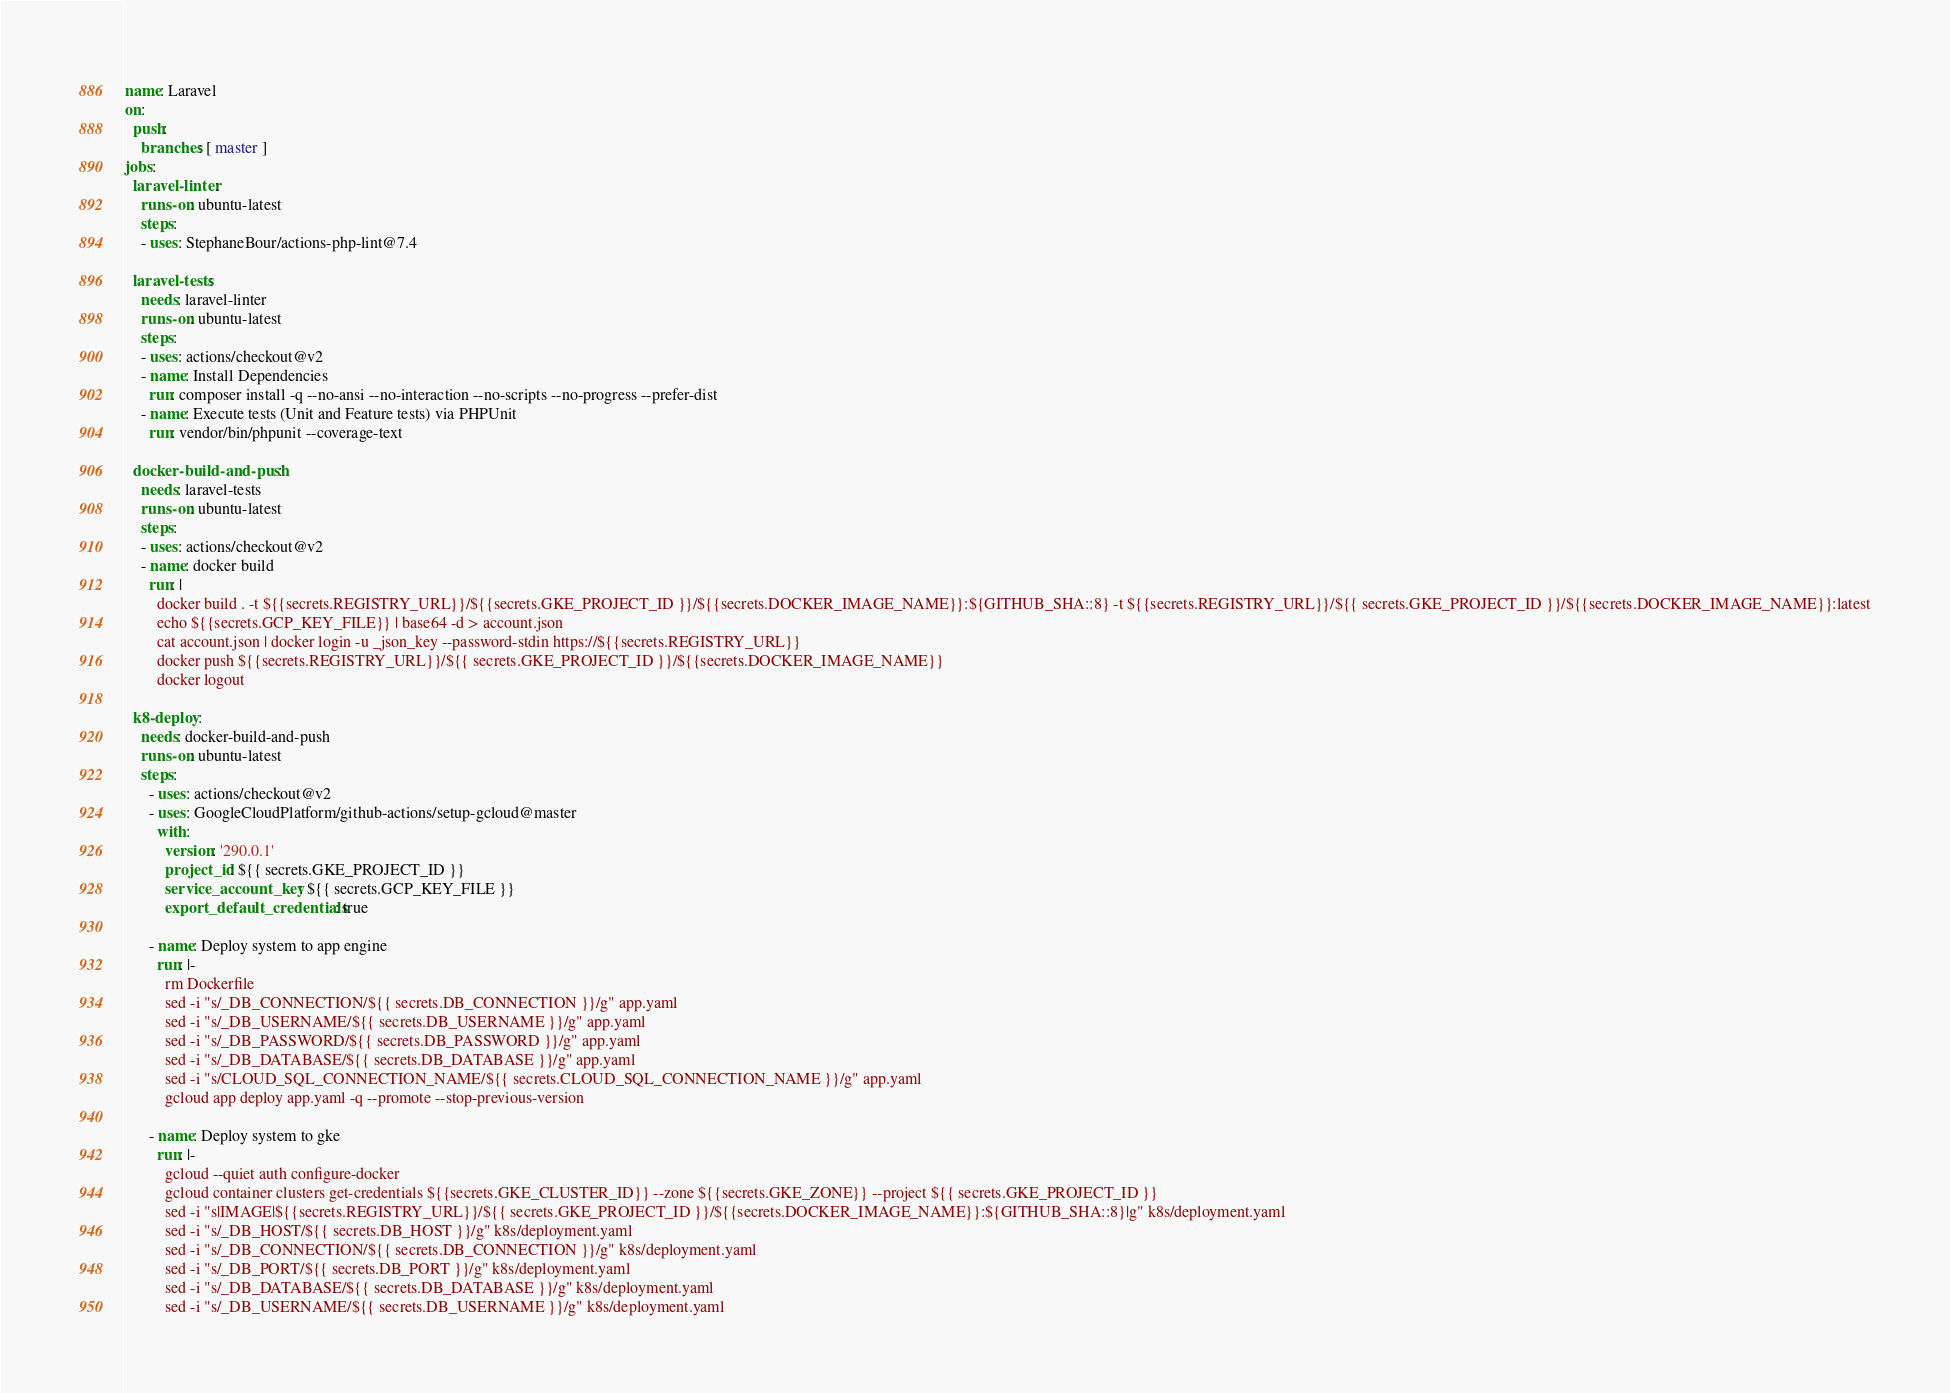<code> <loc_0><loc_0><loc_500><loc_500><_YAML_>name: Laravel
on:
  push:
    branches: [ master ]
jobs:
  laravel-linter:
    runs-on: ubuntu-latest
    steps:
    - uses: StephaneBour/actions-php-lint@7.4

  laravel-tests:
    needs: laravel-linter
    runs-on: ubuntu-latest
    steps:
    - uses: actions/checkout@v2
    - name: Install Dependencies
      run: composer install -q --no-ansi --no-interaction --no-scripts --no-progress --prefer-dist
    - name: Execute tests (Unit and Feature tests) via PHPUnit
      run: vendor/bin/phpunit --coverage-text
  
  docker-build-and-push:
    needs: laravel-tests
    runs-on: ubuntu-latest
    steps:
    - uses: actions/checkout@v2
    - name: docker build
      run: |
        docker build . -t ${{secrets.REGISTRY_URL}}/${{secrets.GKE_PROJECT_ID }}/${{secrets.DOCKER_IMAGE_NAME}}:${GITHUB_SHA::8} -t ${{secrets.REGISTRY_URL}}/${{ secrets.GKE_PROJECT_ID }}/${{secrets.DOCKER_IMAGE_NAME}}:latest
        echo ${{secrets.GCP_KEY_FILE}} | base64 -d > account.json
        cat account.json | docker login -u _json_key --password-stdin https://${{secrets.REGISTRY_URL}}
        docker push ${{secrets.REGISTRY_URL}}/${{ secrets.GKE_PROJECT_ID }}/${{secrets.DOCKER_IMAGE_NAME}}
        docker logout
  
  k8-deploy:
    needs: docker-build-and-push
    runs-on: ubuntu-latest
    steps:
      - uses: actions/checkout@v2
      - uses: GoogleCloudPlatform/github-actions/setup-gcloud@master
        with:
          version: '290.0.1'
          project_id: ${{ secrets.GKE_PROJECT_ID }}
          service_account_key: ${{ secrets.GCP_KEY_FILE }}
          export_default_credentials: true

      - name: Deploy system to app engine
        run: |-
          rm Dockerfile
          sed -i "s/_DB_CONNECTION/${{ secrets.DB_CONNECTION }}/g" app.yaml
          sed -i "s/_DB_USERNAME/${{ secrets.DB_USERNAME }}/g" app.yaml
          sed -i "s/_DB_PASSWORD/${{ secrets.DB_PASSWORD }}/g" app.yaml
          sed -i "s/_DB_DATABASE/${{ secrets.DB_DATABASE }}/g" app.yaml
          sed -i "s/CLOUD_SQL_CONNECTION_NAME/${{ secrets.CLOUD_SQL_CONNECTION_NAME }}/g" app.yaml
          gcloud app deploy app.yaml -q --promote --stop-previous-version
      
      - name: Deploy system to gke
        run: |-
          gcloud --quiet auth configure-docker
          gcloud container clusters get-credentials ${{secrets.GKE_CLUSTER_ID}} --zone ${{secrets.GKE_ZONE}} --project ${{ secrets.GKE_PROJECT_ID }}
          sed -i "s|IMAGE|${{secrets.REGISTRY_URL}}/${{ secrets.GKE_PROJECT_ID }}/${{secrets.DOCKER_IMAGE_NAME}}:${GITHUB_SHA::8}|g" k8s/deployment.yaml
          sed -i "s/_DB_HOST/${{ secrets.DB_HOST }}/g" k8s/deployment.yaml
          sed -i "s/_DB_CONNECTION/${{ secrets.DB_CONNECTION }}/g" k8s/deployment.yaml
          sed -i "s/_DB_PORT/${{ secrets.DB_PORT }}/g" k8s/deployment.yaml
          sed -i "s/_DB_DATABASE/${{ secrets.DB_DATABASE }}/g" k8s/deployment.yaml
          sed -i "s/_DB_USERNAME/${{ secrets.DB_USERNAME }}/g" k8s/deployment.yaml</code> 